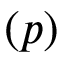<formula> <loc_0><loc_0><loc_500><loc_500>( p )</formula> 